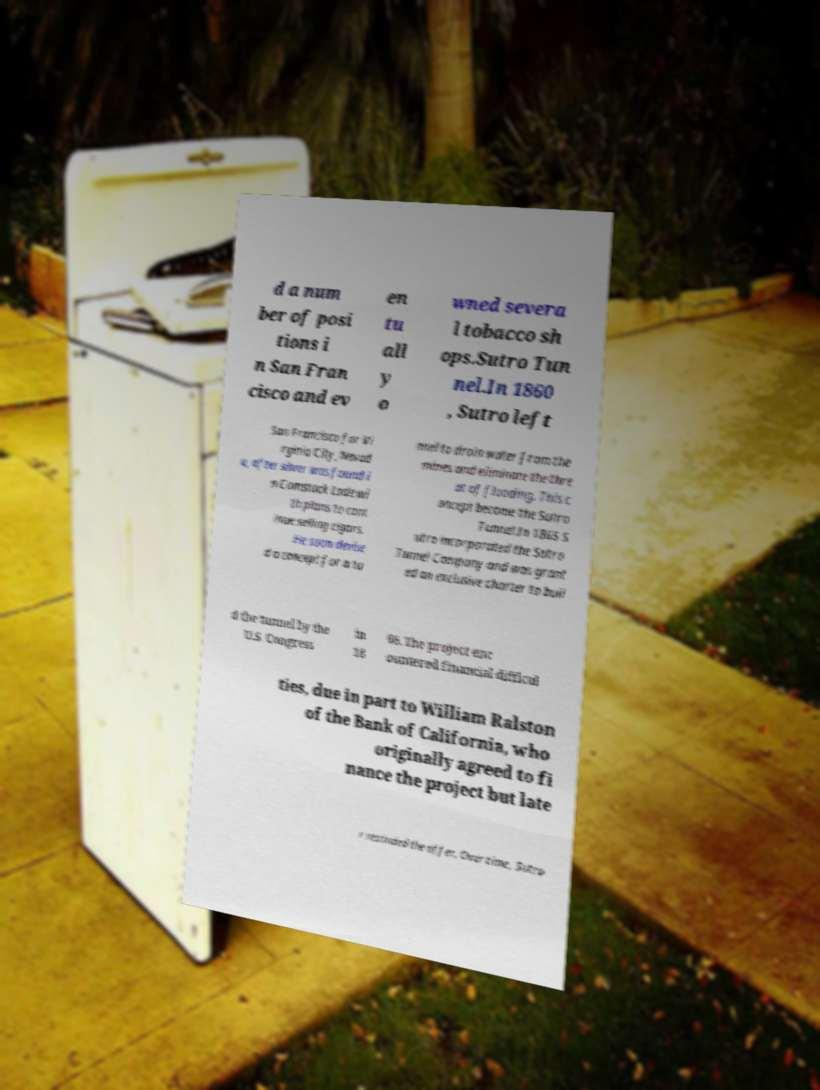Please read and relay the text visible in this image. What does it say? d a num ber of posi tions i n San Fran cisco and ev en tu all y o wned severa l tobacco sh ops.Sutro Tun nel.In 1860 , Sutro left San Francisco for Vi rginia City, Nevad a, after silver was found i n Comstock Lode wi th plans to cont inue selling cigars. He soon devise d a concept for a tu nnel to drain water from the mines and eliminate the thre at of flooding. This c oncept become the Sutro Tunnel.In 1865 S utro incorporated the Sutro Tunnel Company and was grant ed an exclusive charter to buil d the tunnel by the U.S. Congress in 18 66. The project enc ountered financial difficul ties, due in part to William Ralston of the Bank of California, who originally agreed to fi nance the project but late r rescinded the offer. Over time, Sutro 